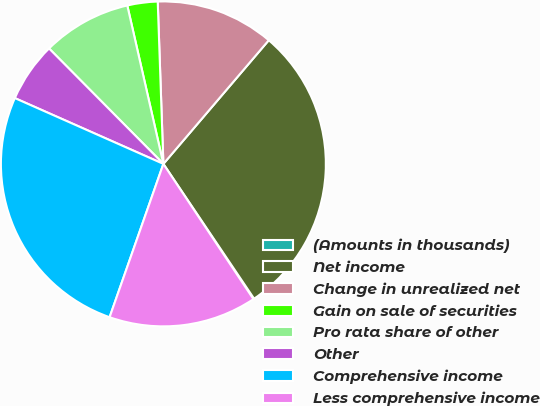<chart> <loc_0><loc_0><loc_500><loc_500><pie_chart><fcel>(Amounts in thousands)<fcel>Net income<fcel>Change in unrealized net<fcel>Gain on sale of securities<fcel>Pro rata share of other<fcel>Other<fcel>Comprehensive income<fcel>Less comprehensive income<nl><fcel>0.08%<fcel>29.34%<fcel>11.79%<fcel>3.01%<fcel>8.86%<fcel>5.94%<fcel>26.27%<fcel>14.72%<nl></chart> 